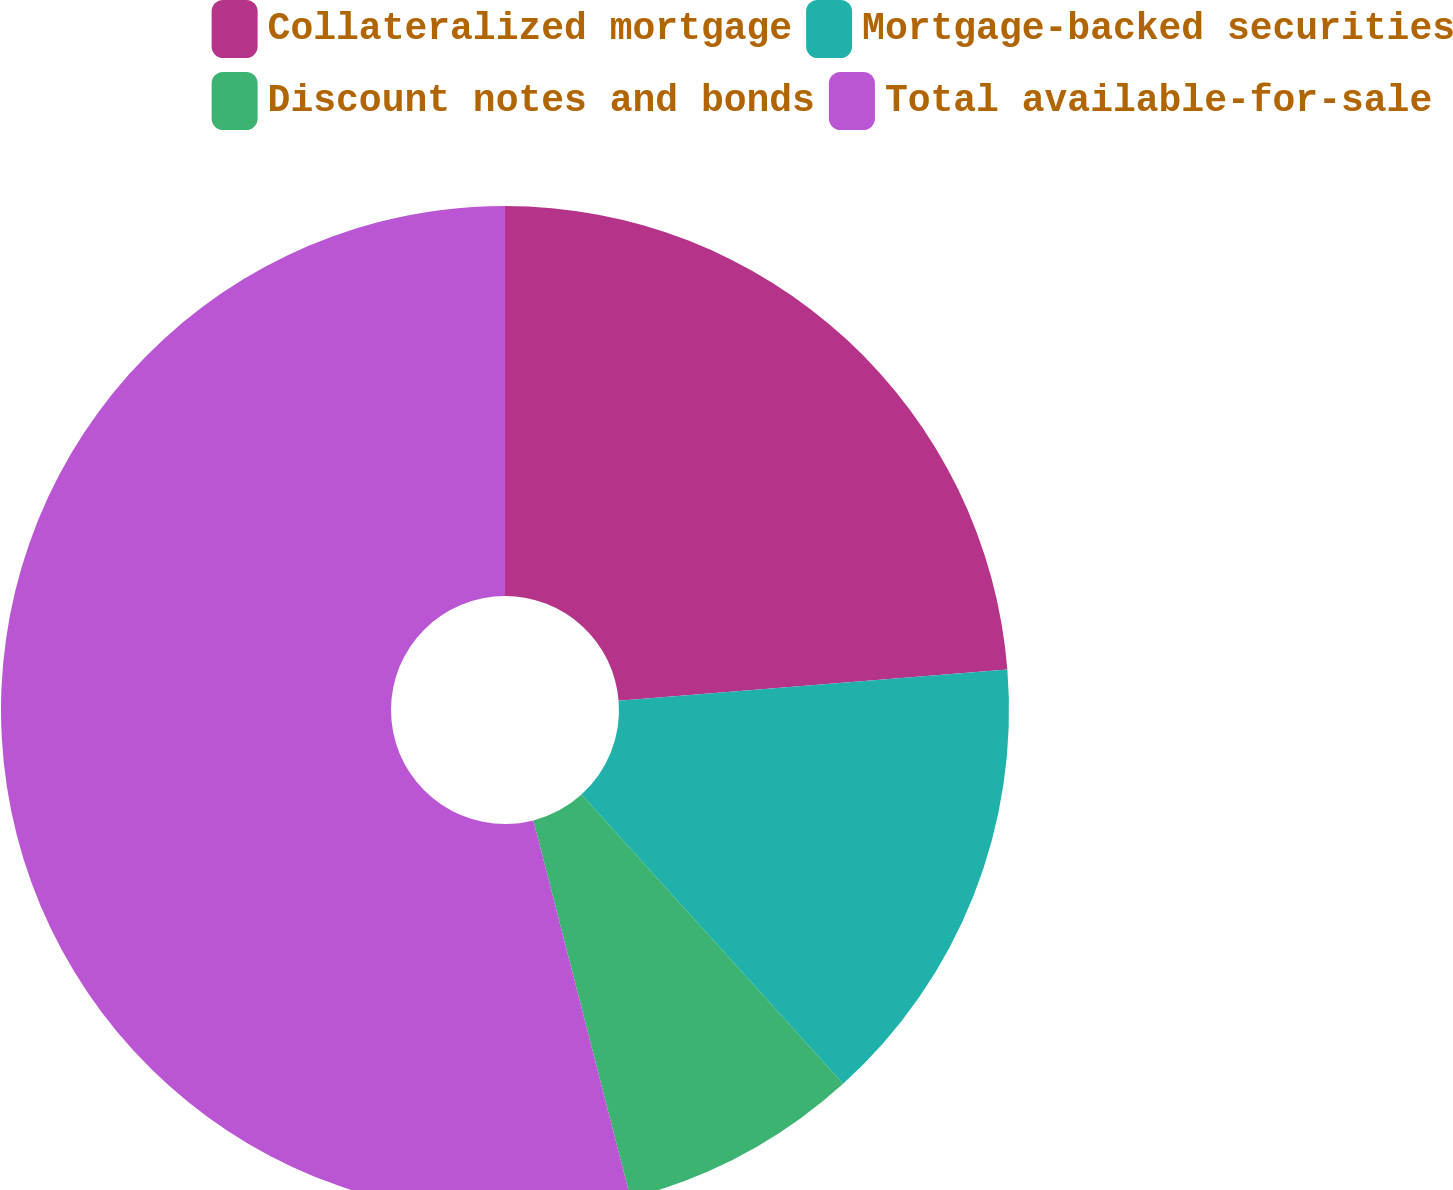Convert chart to OTSL. <chart><loc_0><loc_0><loc_500><loc_500><pie_chart><fcel>Collateralized mortgage<fcel>Mortgage-backed securities<fcel>Discount notes and bonds<fcel>Total available-for-sale<nl><fcel>23.72%<fcel>14.58%<fcel>7.7%<fcel>54.01%<nl></chart> 